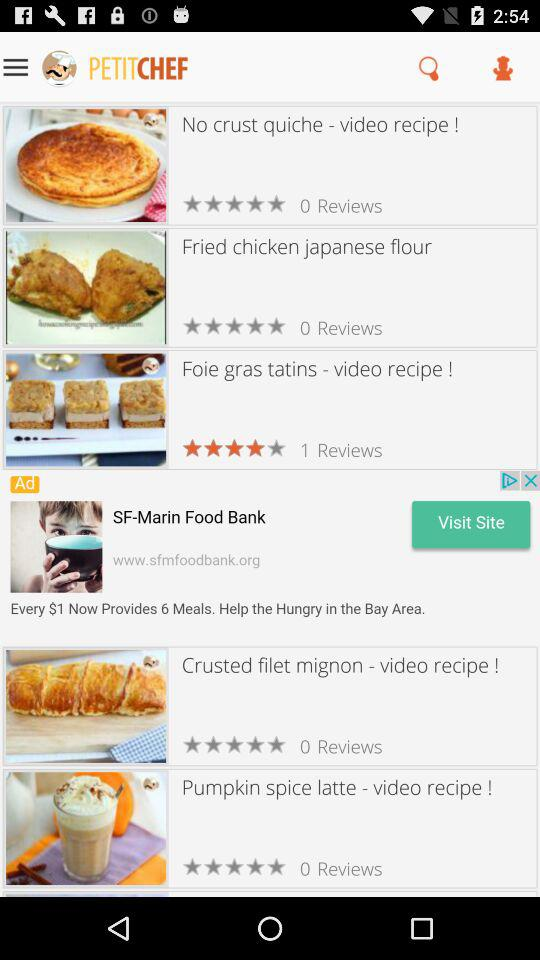How many more reviews does the recipe with the highest number of reviews have than the recipe with the lowest number of reviews?
Answer the question using a single word or phrase. 1 